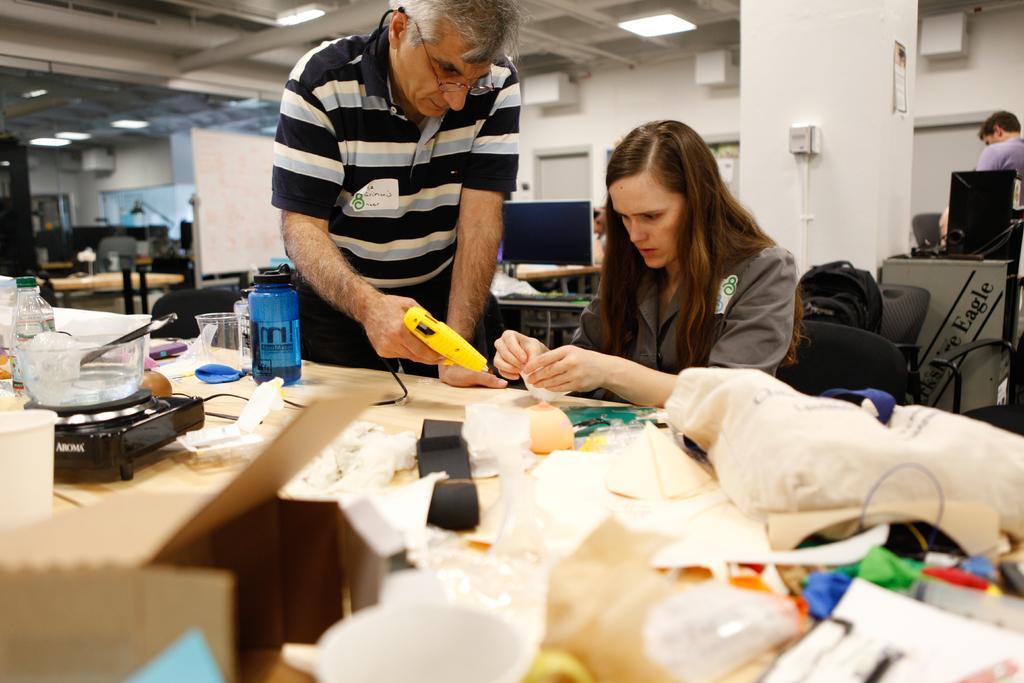How would you summarize this image in a sentence or two? There is a bottle, glass, a spoon in the bowl which is on an object, a box and other objects on a table. In the background, there is a woman sitting and holding an object, there is a person standing and holding an yellow color object, a white color pillar, a person standing, a bag, lights attached to the roof and a white wall. 